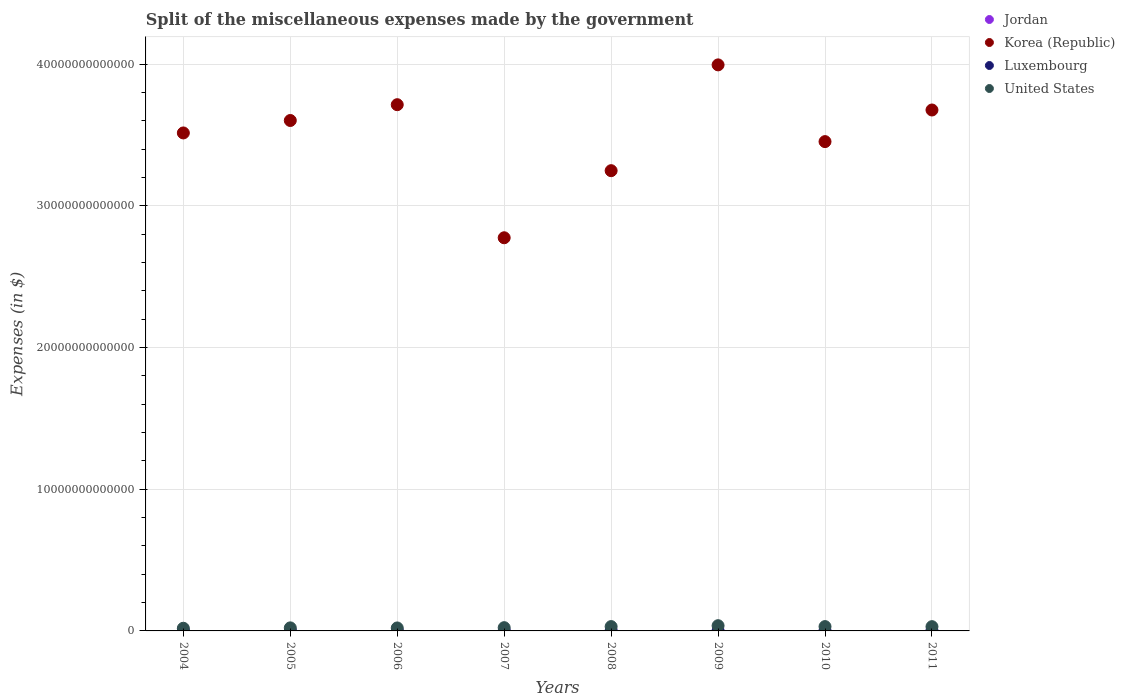How many different coloured dotlines are there?
Make the answer very short. 4. Is the number of dotlines equal to the number of legend labels?
Offer a very short reply. Yes. What is the miscellaneous expenses made by the government in United States in 2006?
Provide a succinct answer. 2.10e+11. Across all years, what is the maximum miscellaneous expenses made by the government in Korea (Republic)?
Offer a terse response. 3.99e+13. Across all years, what is the minimum miscellaneous expenses made by the government in Korea (Republic)?
Keep it short and to the point. 2.77e+13. In which year was the miscellaneous expenses made by the government in United States maximum?
Offer a terse response. 2009. What is the total miscellaneous expenses made by the government in Luxembourg in the graph?
Give a very brief answer. 8.46e+09. What is the difference between the miscellaneous expenses made by the government in Korea (Republic) in 2009 and that in 2010?
Provide a succinct answer. 5.41e+12. What is the difference between the miscellaneous expenses made by the government in Luxembourg in 2004 and the miscellaneous expenses made by the government in Jordan in 2008?
Offer a very short reply. 1.14e+09. What is the average miscellaneous expenses made by the government in Luxembourg per year?
Offer a terse response. 1.06e+09. In the year 2005, what is the difference between the miscellaneous expenses made by the government in United States and miscellaneous expenses made by the government in Jordan?
Offer a very short reply. 2.15e+11. In how many years, is the miscellaneous expenses made by the government in United States greater than 10000000000000 $?
Make the answer very short. 0. What is the ratio of the miscellaneous expenses made by the government in United States in 2005 to that in 2010?
Offer a terse response. 0.71. Is the miscellaneous expenses made by the government in Korea (Republic) in 2005 less than that in 2010?
Your answer should be compact. No. Is the difference between the miscellaneous expenses made by the government in United States in 2005 and 2006 greater than the difference between the miscellaneous expenses made by the government in Jordan in 2005 and 2006?
Keep it short and to the point. Yes. What is the difference between the highest and the second highest miscellaneous expenses made by the government in Jordan?
Provide a short and direct response. 8.96e+08. What is the difference between the highest and the lowest miscellaneous expenses made by the government in Korea (Republic)?
Your answer should be compact. 1.22e+13. In how many years, is the miscellaneous expenses made by the government in Jordan greater than the average miscellaneous expenses made by the government in Jordan taken over all years?
Keep it short and to the point. 2. Is the sum of the miscellaneous expenses made by the government in Korea (Republic) in 2007 and 2009 greater than the maximum miscellaneous expenses made by the government in Jordan across all years?
Your answer should be very brief. Yes. Does the miscellaneous expenses made by the government in Korea (Republic) monotonically increase over the years?
Provide a short and direct response. No. How many dotlines are there?
Provide a short and direct response. 4. What is the difference between two consecutive major ticks on the Y-axis?
Keep it short and to the point. 1.00e+13. Does the graph contain any zero values?
Keep it short and to the point. No. Does the graph contain grids?
Your answer should be very brief. Yes. Where does the legend appear in the graph?
Offer a terse response. Top right. How many legend labels are there?
Give a very brief answer. 4. What is the title of the graph?
Keep it short and to the point. Split of the miscellaneous expenses made by the government. What is the label or title of the X-axis?
Provide a short and direct response. Years. What is the label or title of the Y-axis?
Offer a terse response. Expenses (in $). What is the Expenses (in $) of Jordan in 2004?
Provide a succinct answer. 3.18e+08. What is the Expenses (in $) in Korea (Republic) in 2004?
Offer a very short reply. 3.51e+13. What is the Expenses (in $) in Luxembourg in 2004?
Give a very brief answer. 1.39e+09. What is the Expenses (in $) of United States in 2004?
Ensure brevity in your answer.  1.88e+11. What is the Expenses (in $) in Jordan in 2005?
Your answer should be very brief. 3.57e+08. What is the Expenses (in $) of Korea (Republic) in 2005?
Offer a terse response. 3.60e+13. What is the Expenses (in $) in Luxembourg in 2005?
Your response must be concise. 8.07e+08. What is the Expenses (in $) of United States in 2005?
Your response must be concise. 2.16e+11. What is the Expenses (in $) of Jordan in 2006?
Your answer should be compact. 5.42e+08. What is the Expenses (in $) in Korea (Republic) in 2006?
Offer a terse response. 3.71e+13. What is the Expenses (in $) of Luxembourg in 2006?
Your response must be concise. 8.93e+08. What is the Expenses (in $) in United States in 2006?
Give a very brief answer. 2.10e+11. What is the Expenses (in $) in Jordan in 2007?
Ensure brevity in your answer.  1.44e+09. What is the Expenses (in $) of Korea (Republic) in 2007?
Give a very brief answer. 2.77e+13. What is the Expenses (in $) in Luxembourg in 2007?
Provide a short and direct response. 9.16e+08. What is the Expenses (in $) in United States in 2007?
Keep it short and to the point. 2.30e+11. What is the Expenses (in $) in Jordan in 2008?
Provide a succinct answer. 2.55e+08. What is the Expenses (in $) in Korea (Republic) in 2008?
Your answer should be very brief. 3.25e+13. What is the Expenses (in $) of Luxembourg in 2008?
Offer a terse response. 9.69e+08. What is the Expenses (in $) of United States in 2008?
Make the answer very short. 3.06e+11. What is the Expenses (in $) of Jordan in 2009?
Offer a very short reply. 7.76e+07. What is the Expenses (in $) in Korea (Republic) in 2009?
Your answer should be very brief. 3.99e+13. What is the Expenses (in $) in Luxembourg in 2009?
Ensure brevity in your answer.  1.04e+09. What is the Expenses (in $) of United States in 2009?
Your answer should be very brief. 3.69e+11. What is the Expenses (in $) of Jordan in 2010?
Your response must be concise. 9.67e+07. What is the Expenses (in $) in Korea (Republic) in 2010?
Offer a very short reply. 3.45e+13. What is the Expenses (in $) in Luxembourg in 2010?
Offer a very short reply. 1.15e+09. What is the Expenses (in $) of United States in 2010?
Give a very brief answer. 3.05e+11. What is the Expenses (in $) of Jordan in 2011?
Your answer should be very brief. 8.67e+07. What is the Expenses (in $) of Korea (Republic) in 2011?
Your answer should be very brief. 3.68e+13. What is the Expenses (in $) of Luxembourg in 2011?
Keep it short and to the point. 1.28e+09. What is the Expenses (in $) of United States in 2011?
Offer a very short reply. 3.01e+11. Across all years, what is the maximum Expenses (in $) in Jordan?
Offer a very short reply. 1.44e+09. Across all years, what is the maximum Expenses (in $) in Korea (Republic)?
Make the answer very short. 3.99e+13. Across all years, what is the maximum Expenses (in $) of Luxembourg?
Provide a short and direct response. 1.39e+09. Across all years, what is the maximum Expenses (in $) in United States?
Your answer should be very brief. 3.69e+11. Across all years, what is the minimum Expenses (in $) of Jordan?
Provide a succinct answer. 7.76e+07. Across all years, what is the minimum Expenses (in $) in Korea (Republic)?
Your response must be concise. 2.77e+13. Across all years, what is the minimum Expenses (in $) of Luxembourg?
Make the answer very short. 8.07e+08. Across all years, what is the minimum Expenses (in $) in United States?
Make the answer very short. 1.88e+11. What is the total Expenses (in $) in Jordan in the graph?
Keep it short and to the point. 3.17e+09. What is the total Expenses (in $) of Korea (Republic) in the graph?
Provide a short and direct response. 2.80e+14. What is the total Expenses (in $) in Luxembourg in the graph?
Make the answer very short. 8.46e+09. What is the total Expenses (in $) in United States in the graph?
Offer a very short reply. 2.12e+12. What is the difference between the Expenses (in $) of Jordan in 2004 and that in 2005?
Give a very brief answer. -3.92e+07. What is the difference between the Expenses (in $) in Korea (Republic) in 2004 and that in 2005?
Offer a very short reply. -8.79e+11. What is the difference between the Expenses (in $) of Luxembourg in 2004 and that in 2005?
Your answer should be compact. 5.87e+08. What is the difference between the Expenses (in $) in United States in 2004 and that in 2005?
Give a very brief answer. -2.72e+1. What is the difference between the Expenses (in $) in Jordan in 2004 and that in 2006?
Offer a very short reply. -2.24e+08. What is the difference between the Expenses (in $) of Korea (Republic) in 2004 and that in 2006?
Provide a short and direct response. -1.99e+12. What is the difference between the Expenses (in $) in Luxembourg in 2004 and that in 2006?
Offer a terse response. 5.02e+08. What is the difference between the Expenses (in $) in United States in 2004 and that in 2006?
Keep it short and to the point. -2.14e+1. What is the difference between the Expenses (in $) of Jordan in 2004 and that in 2007?
Ensure brevity in your answer.  -1.12e+09. What is the difference between the Expenses (in $) of Korea (Republic) in 2004 and that in 2007?
Make the answer very short. 7.40e+12. What is the difference between the Expenses (in $) in Luxembourg in 2004 and that in 2007?
Your response must be concise. 4.79e+08. What is the difference between the Expenses (in $) in United States in 2004 and that in 2007?
Offer a very short reply. -4.16e+1. What is the difference between the Expenses (in $) in Jordan in 2004 and that in 2008?
Your response must be concise. 6.25e+07. What is the difference between the Expenses (in $) in Korea (Republic) in 2004 and that in 2008?
Your response must be concise. 2.66e+12. What is the difference between the Expenses (in $) of Luxembourg in 2004 and that in 2008?
Make the answer very short. 4.26e+08. What is the difference between the Expenses (in $) of United States in 2004 and that in 2008?
Your answer should be compact. -1.18e+11. What is the difference between the Expenses (in $) in Jordan in 2004 and that in 2009?
Give a very brief answer. 2.40e+08. What is the difference between the Expenses (in $) in Korea (Republic) in 2004 and that in 2009?
Give a very brief answer. -4.80e+12. What is the difference between the Expenses (in $) of Luxembourg in 2004 and that in 2009?
Provide a succinct answer. 3.50e+08. What is the difference between the Expenses (in $) of United States in 2004 and that in 2009?
Your answer should be very brief. -1.81e+11. What is the difference between the Expenses (in $) in Jordan in 2004 and that in 2010?
Keep it short and to the point. 2.21e+08. What is the difference between the Expenses (in $) of Korea (Republic) in 2004 and that in 2010?
Offer a very short reply. 6.11e+11. What is the difference between the Expenses (in $) of Luxembourg in 2004 and that in 2010?
Give a very brief answer. 2.46e+08. What is the difference between the Expenses (in $) of United States in 2004 and that in 2010?
Your answer should be compact. -1.17e+11. What is the difference between the Expenses (in $) in Jordan in 2004 and that in 2011?
Your response must be concise. 2.31e+08. What is the difference between the Expenses (in $) in Korea (Republic) in 2004 and that in 2011?
Offer a terse response. -1.62e+12. What is the difference between the Expenses (in $) of Luxembourg in 2004 and that in 2011?
Offer a very short reply. 1.10e+08. What is the difference between the Expenses (in $) of United States in 2004 and that in 2011?
Make the answer very short. -1.12e+11. What is the difference between the Expenses (in $) of Jordan in 2005 and that in 2006?
Keep it short and to the point. -1.85e+08. What is the difference between the Expenses (in $) of Korea (Republic) in 2005 and that in 2006?
Provide a short and direct response. -1.12e+12. What is the difference between the Expenses (in $) of Luxembourg in 2005 and that in 2006?
Offer a terse response. -8.55e+07. What is the difference between the Expenses (in $) of United States in 2005 and that in 2006?
Offer a very short reply. 5.80e+09. What is the difference between the Expenses (in $) in Jordan in 2005 and that in 2007?
Provide a short and direct response. -1.08e+09. What is the difference between the Expenses (in $) of Korea (Republic) in 2005 and that in 2007?
Your answer should be compact. 8.28e+12. What is the difference between the Expenses (in $) of Luxembourg in 2005 and that in 2007?
Offer a very short reply. -1.09e+08. What is the difference between the Expenses (in $) in United States in 2005 and that in 2007?
Keep it short and to the point. -1.44e+1. What is the difference between the Expenses (in $) in Jordan in 2005 and that in 2008?
Ensure brevity in your answer.  1.02e+08. What is the difference between the Expenses (in $) of Korea (Republic) in 2005 and that in 2008?
Offer a very short reply. 3.54e+12. What is the difference between the Expenses (in $) in Luxembourg in 2005 and that in 2008?
Give a very brief answer. -1.62e+08. What is the difference between the Expenses (in $) in United States in 2005 and that in 2008?
Your response must be concise. -9.04e+1. What is the difference between the Expenses (in $) in Jordan in 2005 and that in 2009?
Offer a terse response. 2.80e+08. What is the difference between the Expenses (in $) of Korea (Republic) in 2005 and that in 2009?
Offer a very short reply. -3.93e+12. What is the difference between the Expenses (in $) in Luxembourg in 2005 and that in 2009?
Your response must be concise. -2.37e+08. What is the difference between the Expenses (in $) in United States in 2005 and that in 2009?
Provide a short and direct response. -1.54e+11. What is the difference between the Expenses (in $) in Jordan in 2005 and that in 2010?
Make the answer very short. 2.60e+08. What is the difference between the Expenses (in $) of Korea (Republic) in 2005 and that in 2010?
Offer a very short reply. 1.49e+12. What is the difference between the Expenses (in $) in Luxembourg in 2005 and that in 2010?
Offer a terse response. -3.41e+08. What is the difference between the Expenses (in $) in United States in 2005 and that in 2010?
Your answer should be compact. -8.99e+1. What is the difference between the Expenses (in $) of Jordan in 2005 and that in 2011?
Make the answer very short. 2.70e+08. What is the difference between the Expenses (in $) in Korea (Republic) in 2005 and that in 2011?
Provide a short and direct response. -7.41e+11. What is the difference between the Expenses (in $) in Luxembourg in 2005 and that in 2011?
Keep it short and to the point. -4.77e+08. What is the difference between the Expenses (in $) of United States in 2005 and that in 2011?
Offer a very short reply. -8.51e+1. What is the difference between the Expenses (in $) of Jordan in 2006 and that in 2007?
Give a very brief answer. -8.96e+08. What is the difference between the Expenses (in $) of Korea (Republic) in 2006 and that in 2007?
Ensure brevity in your answer.  9.39e+12. What is the difference between the Expenses (in $) in Luxembourg in 2006 and that in 2007?
Offer a very short reply. -2.33e+07. What is the difference between the Expenses (in $) of United States in 2006 and that in 2007?
Give a very brief answer. -2.02e+1. What is the difference between the Expenses (in $) in Jordan in 2006 and that in 2008?
Make the answer very short. 2.87e+08. What is the difference between the Expenses (in $) in Korea (Republic) in 2006 and that in 2008?
Keep it short and to the point. 4.66e+12. What is the difference between the Expenses (in $) of Luxembourg in 2006 and that in 2008?
Keep it short and to the point. -7.64e+07. What is the difference between the Expenses (in $) in United States in 2006 and that in 2008?
Provide a short and direct response. -9.62e+1. What is the difference between the Expenses (in $) in Jordan in 2006 and that in 2009?
Provide a succinct answer. 4.65e+08. What is the difference between the Expenses (in $) in Korea (Republic) in 2006 and that in 2009?
Provide a short and direct response. -2.81e+12. What is the difference between the Expenses (in $) in Luxembourg in 2006 and that in 2009?
Your response must be concise. -1.52e+08. What is the difference between the Expenses (in $) of United States in 2006 and that in 2009?
Provide a succinct answer. -1.60e+11. What is the difference between the Expenses (in $) in Jordan in 2006 and that in 2010?
Keep it short and to the point. 4.46e+08. What is the difference between the Expenses (in $) in Korea (Republic) in 2006 and that in 2010?
Offer a terse response. 2.61e+12. What is the difference between the Expenses (in $) of Luxembourg in 2006 and that in 2010?
Your answer should be very brief. -2.56e+08. What is the difference between the Expenses (in $) of United States in 2006 and that in 2010?
Give a very brief answer. -9.57e+1. What is the difference between the Expenses (in $) in Jordan in 2006 and that in 2011?
Offer a terse response. 4.56e+08. What is the difference between the Expenses (in $) of Korea (Republic) in 2006 and that in 2011?
Provide a succinct answer. 3.75e+11. What is the difference between the Expenses (in $) in Luxembourg in 2006 and that in 2011?
Your answer should be compact. -3.92e+08. What is the difference between the Expenses (in $) in United States in 2006 and that in 2011?
Your response must be concise. -9.09e+1. What is the difference between the Expenses (in $) of Jordan in 2007 and that in 2008?
Give a very brief answer. 1.18e+09. What is the difference between the Expenses (in $) in Korea (Republic) in 2007 and that in 2008?
Your answer should be compact. -4.73e+12. What is the difference between the Expenses (in $) in Luxembourg in 2007 and that in 2008?
Your answer should be compact. -5.31e+07. What is the difference between the Expenses (in $) in United States in 2007 and that in 2008?
Offer a terse response. -7.60e+1. What is the difference between the Expenses (in $) in Jordan in 2007 and that in 2009?
Make the answer very short. 1.36e+09. What is the difference between the Expenses (in $) of Korea (Republic) in 2007 and that in 2009?
Offer a very short reply. -1.22e+13. What is the difference between the Expenses (in $) in Luxembourg in 2007 and that in 2009?
Offer a terse response. -1.28e+08. What is the difference between the Expenses (in $) in United States in 2007 and that in 2009?
Provide a succinct answer. -1.39e+11. What is the difference between the Expenses (in $) in Jordan in 2007 and that in 2010?
Offer a very short reply. 1.34e+09. What is the difference between the Expenses (in $) of Korea (Republic) in 2007 and that in 2010?
Keep it short and to the point. -6.79e+12. What is the difference between the Expenses (in $) of Luxembourg in 2007 and that in 2010?
Make the answer very short. -2.33e+08. What is the difference between the Expenses (in $) of United States in 2007 and that in 2010?
Provide a succinct answer. -7.55e+1. What is the difference between the Expenses (in $) in Jordan in 2007 and that in 2011?
Your answer should be compact. 1.35e+09. What is the difference between the Expenses (in $) of Korea (Republic) in 2007 and that in 2011?
Offer a terse response. -9.02e+12. What is the difference between the Expenses (in $) in Luxembourg in 2007 and that in 2011?
Your answer should be compact. -3.69e+08. What is the difference between the Expenses (in $) of United States in 2007 and that in 2011?
Provide a succinct answer. -7.07e+1. What is the difference between the Expenses (in $) of Jordan in 2008 and that in 2009?
Keep it short and to the point. 1.78e+08. What is the difference between the Expenses (in $) in Korea (Republic) in 2008 and that in 2009?
Give a very brief answer. -7.47e+12. What is the difference between the Expenses (in $) in Luxembourg in 2008 and that in 2009?
Offer a very short reply. -7.53e+07. What is the difference between the Expenses (in $) in United States in 2008 and that in 2009?
Provide a succinct answer. -6.33e+1. What is the difference between the Expenses (in $) in Jordan in 2008 and that in 2010?
Your response must be concise. 1.59e+08. What is the difference between the Expenses (in $) in Korea (Republic) in 2008 and that in 2010?
Your answer should be very brief. -2.05e+12. What is the difference between the Expenses (in $) of Luxembourg in 2008 and that in 2010?
Offer a terse response. -1.79e+08. What is the difference between the Expenses (in $) of Jordan in 2008 and that in 2011?
Your answer should be compact. 1.69e+08. What is the difference between the Expenses (in $) of Korea (Republic) in 2008 and that in 2011?
Your response must be concise. -4.28e+12. What is the difference between the Expenses (in $) in Luxembourg in 2008 and that in 2011?
Your answer should be compact. -3.15e+08. What is the difference between the Expenses (in $) in United States in 2008 and that in 2011?
Offer a terse response. 5.30e+09. What is the difference between the Expenses (in $) of Jordan in 2009 and that in 2010?
Provide a succinct answer. -1.91e+07. What is the difference between the Expenses (in $) of Korea (Republic) in 2009 and that in 2010?
Your answer should be compact. 5.41e+12. What is the difference between the Expenses (in $) of Luxembourg in 2009 and that in 2010?
Your answer should be very brief. -1.04e+08. What is the difference between the Expenses (in $) in United States in 2009 and that in 2010?
Give a very brief answer. 6.38e+1. What is the difference between the Expenses (in $) in Jordan in 2009 and that in 2011?
Your response must be concise. -9.10e+06. What is the difference between the Expenses (in $) of Korea (Republic) in 2009 and that in 2011?
Offer a terse response. 3.18e+12. What is the difference between the Expenses (in $) of Luxembourg in 2009 and that in 2011?
Offer a terse response. -2.40e+08. What is the difference between the Expenses (in $) in United States in 2009 and that in 2011?
Offer a terse response. 6.86e+1. What is the difference between the Expenses (in $) in Korea (Republic) in 2010 and that in 2011?
Provide a short and direct response. -2.23e+12. What is the difference between the Expenses (in $) of Luxembourg in 2010 and that in 2011?
Make the answer very short. -1.36e+08. What is the difference between the Expenses (in $) of United States in 2010 and that in 2011?
Ensure brevity in your answer.  4.80e+09. What is the difference between the Expenses (in $) of Jordan in 2004 and the Expenses (in $) of Korea (Republic) in 2005?
Provide a succinct answer. -3.60e+13. What is the difference between the Expenses (in $) of Jordan in 2004 and the Expenses (in $) of Luxembourg in 2005?
Provide a succinct answer. -4.89e+08. What is the difference between the Expenses (in $) of Jordan in 2004 and the Expenses (in $) of United States in 2005?
Offer a very short reply. -2.15e+11. What is the difference between the Expenses (in $) in Korea (Republic) in 2004 and the Expenses (in $) in Luxembourg in 2005?
Your answer should be compact. 3.51e+13. What is the difference between the Expenses (in $) in Korea (Republic) in 2004 and the Expenses (in $) in United States in 2005?
Make the answer very short. 3.49e+13. What is the difference between the Expenses (in $) in Luxembourg in 2004 and the Expenses (in $) in United States in 2005?
Your response must be concise. -2.14e+11. What is the difference between the Expenses (in $) in Jordan in 2004 and the Expenses (in $) in Korea (Republic) in 2006?
Offer a very short reply. -3.71e+13. What is the difference between the Expenses (in $) of Jordan in 2004 and the Expenses (in $) of Luxembourg in 2006?
Provide a succinct answer. -5.75e+08. What is the difference between the Expenses (in $) in Jordan in 2004 and the Expenses (in $) in United States in 2006?
Offer a very short reply. -2.09e+11. What is the difference between the Expenses (in $) of Korea (Republic) in 2004 and the Expenses (in $) of Luxembourg in 2006?
Provide a succinct answer. 3.51e+13. What is the difference between the Expenses (in $) of Korea (Republic) in 2004 and the Expenses (in $) of United States in 2006?
Offer a terse response. 3.49e+13. What is the difference between the Expenses (in $) of Luxembourg in 2004 and the Expenses (in $) of United States in 2006?
Ensure brevity in your answer.  -2.08e+11. What is the difference between the Expenses (in $) of Jordan in 2004 and the Expenses (in $) of Korea (Republic) in 2007?
Your response must be concise. -2.77e+13. What is the difference between the Expenses (in $) of Jordan in 2004 and the Expenses (in $) of Luxembourg in 2007?
Your answer should be compact. -5.98e+08. What is the difference between the Expenses (in $) in Jordan in 2004 and the Expenses (in $) in United States in 2007?
Provide a short and direct response. -2.30e+11. What is the difference between the Expenses (in $) of Korea (Republic) in 2004 and the Expenses (in $) of Luxembourg in 2007?
Provide a succinct answer. 3.51e+13. What is the difference between the Expenses (in $) in Korea (Republic) in 2004 and the Expenses (in $) in United States in 2007?
Provide a short and direct response. 3.49e+13. What is the difference between the Expenses (in $) of Luxembourg in 2004 and the Expenses (in $) of United States in 2007?
Make the answer very short. -2.29e+11. What is the difference between the Expenses (in $) of Jordan in 2004 and the Expenses (in $) of Korea (Republic) in 2008?
Give a very brief answer. -3.25e+13. What is the difference between the Expenses (in $) of Jordan in 2004 and the Expenses (in $) of Luxembourg in 2008?
Give a very brief answer. -6.51e+08. What is the difference between the Expenses (in $) in Jordan in 2004 and the Expenses (in $) in United States in 2008?
Your answer should be very brief. -3.06e+11. What is the difference between the Expenses (in $) in Korea (Republic) in 2004 and the Expenses (in $) in Luxembourg in 2008?
Give a very brief answer. 3.51e+13. What is the difference between the Expenses (in $) in Korea (Republic) in 2004 and the Expenses (in $) in United States in 2008?
Offer a terse response. 3.48e+13. What is the difference between the Expenses (in $) of Luxembourg in 2004 and the Expenses (in $) of United States in 2008?
Your answer should be compact. -3.05e+11. What is the difference between the Expenses (in $) in Jordan in 2004 and the Expenses (in $) in Korea (Republic) in 2009?
Offer a terse response. -3.99e+13. What is the difference between the Expenses (in $) in Jordan in 2004 and the Expenses (in $) in Luxembourg in 2009?
Offer a terse response. -7.27e+08. What is the difference between the Expenses (in $) in Jordan in 2004 and the Expenses (in $) in United States in 2009?
Your answer should be very brief. -3.69e+11. What is the difference between the Expenses (in $) in Korea (Republic) in 2004 and the Expenses (in $) in Luxembourg in 2009?
Make the answer very short. 3.51e+13. What is the difference between the Expenses (in $) of Korea (Republic) in 2004 and the Expenses (in $) of United States in 2009?
Keep it short and to the point. 3.48e+13. What is the difference between the Expenses (in $) of Luxembourg in 2004 and the Expenses (in $) of United States in 2009?
Your response must be concise. -3.68e+11. What is the difference between the Expenses (in $) in Jordan in 2004 and the Expenses (in $) in Korea (Republic) in 2010?
Give a very brief answer. -3.45e+13. What is the difference between the Expenses (in $) of Jordan in 2004 and the Expenses (in $) of Luxembourg in 2010?
Your response must be concise. -8.31e+08. What is the difference between the Expenses (in $) of Jordan in 2004 and the Expenses (in $) of United States in 2010?
Make the answer very short. -3.05e+11. What is the difference between the Expenses (in $) in Korea (Republic) in 2004 and the Expenses (in $) in Luxembourg in 2010?
Offer a terse response. 3.51e+13. What is the difference between the Expenses (in $) in Korea (Republic) in 2004 and the Expenses (in $) in United States in 2010?
Make the answer very short. 3.48e+13. What is the difference between the Expenses (in $) of Luxembourg in 2004 and the Expenses (in $) of United States in 2010?
Provide a succinct answer. -3.04e+11. What is the difference between the Expenses (in $) of Jordan in 2004 and the Expenses (in $) of Korea (Republic) in 2011?
Make the answer very short. -3.68e+13. What is the difference between the Expenses (in $) of Jordan in 2004 and the Expenses (in $) of Luxembourg in 2011?
Make the answer very short. -9.67e+08. What is the difference between the Expenses (in $) of Jordan in 2004 and the Expenses (in $) of United States in 2011?
Keep it short and to the point. -3.00e+11. What is the difference between the Expenses (in $) in Korea (Republic) in 2004 and the Expenses (in $) in Luxembourg in 2011?
Keep it short and to the point. 3.51e+13. What is the difference between the Expenses (in $) of Korea (Republic) in 2004 and the Expenses (in $) of United States in 2011?
Offer a terse response. 3.48e+13. What is the difference between the Expenses (in $) of Luxembourg in 2004 and the Expenses (in $) of United States in 2011?
Provide a succinct answer. -2.99e+11. What is the difference between the Expenses (in $) of Jordan in 2005 and the Expenses (in $) of Korea (Republic) in 2006?
Your response must be concise. -3.71e+13. What is the difference between the Expenses (in $) of Jordan in 2005 and the Expenses (in $) of Luxembourg in 2006?
Your answer should be compact. -5.36e+08. What is the difference between the Expenses (in $) in Jordan in 2005 and the Expenses (in $) in United States in 2006?
Provide a succinct answer. -2.09e+11. What is the difference between the Expenses (in $) in Korea (Republic) in 2005 and the Expenses (in $) in Luxembourg in 2006?
Make the answer very short. 3.60e+13. What is the difference between the Expenses (in $) in Korea (Republic) in 2005 and the Expenses (in $) in United States in 2006?
Make the answer very short. 3.58e+13. What is the difference between the Expenses (in $) in Luxembourg in 2005 and the Expenses (in $) in United States in 2006?
Ensure brevity in your answer.  -2.09e+11. What is the difference between the Expenses (in $) of Jordan in 2005 and the Expenses (in $) of Korea (Republic) in 2007?
Provide a succinct answer. -2.77e+13. What is the difference between the Expenses (in $) in Jordan in 2005 and the Expenses (in $) in Luxembourg in 2007?
Ensure brevity in your answer.  -5.59e+08. What is the difference between the Expenses (in $) of Jordan in 2005 and the Expenses (in $) of United States in 2007?
Make the answer very short. -2.30e+11. What is the difference between the Expenses (in $) of Korea (Republic) in 2005 and the Expenses (in $) of Luxembourg in 2007?
Offer a very short reply. 3.60e+13. What is the difference between the Expenses (in $) in Korea (Republic) in 2005 and the Expenses (in $) in United States in 2007?
Make the answer very short. 3.58e+13. What is the difference between the Expenses (in $) in Luxembourg in 2005 and the Expenses (in $) in United States in 2007?
Make the answer very short. -2.29e+11. What is the difference between the Expenses (in $) in Jordan in 2005 and the Expenses (in $) in Korea (Republic) in 2008?
Your answer should be very brief. -3.25e+13. What is the difference between the Expenses (in $) of Jordan in 2005 and the Expenses (in $) of Luxembourg in 2008?
Give a very brief answer. -6.12e+08. What is the difference between the Expenses (in $) in Jordan in 2005 and the Expenses (in $) in United States in 2008?
Make the answer very short. -3.06e+11. What is the difference between the Expenses (in $) in Korea (Republic) in 2005 and the Expenses (in $) in Luxembourg in 2008?
Offer a terse response. 3.60e+13. What is the difference between the Expenses (in $) of Korea (Republic) in 2005 and the Expenses (in $) of United States in 2008?
Keep it short and to the point. 3.57e+13. What is the difference between the Expenses (in $) of Luxembourg in 2005 and the Expenses (in $) of United States in 2008?
Keep it short and to the point. -3.05e+11. What is the difference between the Expenses (in $) of Jordan in 2005 and the Expenses (in $) of Korea (Republic) in 2009?
Your answer should be very brief. -3.99e+13. What is the difference between the Expenses (in $) of Jordan in 2005 and the Expenses (in $) of Luxembourg in 2009?
Keep it short and to the point. -6.87e+08. What is the difference between the Expenses (in $) of Jordan in 2005 and the Expenses (in $) of United States in 2009?
Offer a terse response. -3.69e+11. What is the difference between the Expenses (in $) of Korea (Republic) in 2005 and the Expenses (in $) of Luxembourg in 2009?
Offer a terse response. 3.60e+13. What is the difference between the Expenses (in $) in Korea (Republic) in 2005 and the Expenses (in $) in United States in 2009?
Your response must be concise. 3.57e+13. What is the difference between the Expenses (in $) in Luxembourg in 2005 and the Expenses (in $) in United States in 2009?
Your answer should be very brief. -3.68e+11. What is the difference between the Expenses (in $) of Jordan in 2005 and the Expenses (in $) of Korea (Republic) in 2010?
Offer a very short reply. -3.45e+13. What is the difference between the Expenses (in $) of Jordan in 2005 and the Expenses (in $) of Luxembourg in 2010?
Keep it short and to the point. -7.91e+08. What is the difference between the Expenses (in $) in Jordan in 2005 and the Expenses (in $) in United States in 2010?
Provide a succinct answer. -3.05e+11. What is the difference between the Expenses (in $) of Korea (Republic) in 2005 and the Expenses (in $) of Luxembourg in 2010?
Offer a terse response. 3.60e+13. What is the difference between the Expenses (in $) of Korea (Republic) in 2005 and the Expenses (in $) of United States in 2010?
Provide a succinct answer. 3.57e+13. What is the difference between the Expenses (in $) of Luxembourg in 2005 and the Expenses (in $) of United States in 2010?
Your answer should be compact. -3.05e+11. What is the difference between the Expenses (in $) in Jordan in 2005 and the Expenses (in $) in Korea (Republic) in 2011?
Offer a terse response. -3.68e+13. What is the difference between the Expenses (in $) of Jordan in 2005 and the Expenses (in $) of Luxembourg in 2011?
Your answer should be compact. -9.27e+08. What is the difference between the Expenses (in $) of Jordan in 2005 and the Expenses (in $) of United States in 2011?
Offer a very short reply. -3.00e+11. What is the difference between the Expenses (in $) of Korea (Republic) in 2005 and the Expenses (in $) of Luxembourg in 2011?
Your answer should be compact. 3.60e+13. What is the difference between the Expenses (in $) in Korea (Republic) in 2005 and the Expenses (in $) in United States in 2011?
Provide a short and direct response. 3.57e+13. What is the difference between the Expenses (in $) in Luxembourg in 2005 and the Expenses (in $) in United States in 2011?
Ensure brevity in your answer.  -3.00e+11. What is the difference between the Expenses (in $) of Jordan in 2006 and the Expenses (in $) of Korea (Republic) in 2007?
Give a very brief answer. -2.77e+13. What is the difference between the Expenses (in $) in Jordan in 2006 and the Expenses (in $) in Luxembourg in 2007?
Ensure brevity in your answer.  -3.74e+08. What is the difference between the Expenses (in $) in Jordan in 2006 and the Expenses (in $) in United States in 2007?
Offer a terse response. -2.29e+11. What is the difference between the Expenses (in $) in Korea (Republic) in 2006 and the Expenses (in $) in Luxembourg in 2007?
Keep it short and to the point. 3.71e+13. What is the difference between the Expenses (in $) in Korea (Republic) in 2006 and the Expenses (in $) in United States in 2007?
Offer a terse response. 3.69e+13. What is the difference between the Expenses (in $) in Luxembourg in 2006 and the Expenses (in $) in United States in 2007?
Offer a terse response. -2.29e+11. What is the difference between the Expenses (in $) of Jordan in 2006 and the Expenses (in $) of Korea (Republic) in 2008?
Provide a short and direct response. -3.25e+13. What is the difference between the Expenses (in $) in Jordan in 2006 and the Expenses (in $) in Luxembourg in 2008?
Ensure brevity in your answer.  -4.27e+08. What is the difference between the Expenses (in $) in Jordan in 2006 and the Expenses (in $) in United States in 2008?
Provide a short and direct response. -3.05e+11. What is the difference between the Expenses (in $) in Korea (Republic) in 2006 and the Expenses (in $) in Luxembourg in 2008?
Your answer should be very brief. 3.71e+13. What is the difference between the Expenses (in $) of Korea (Republic) in 2006 and the Expenses (in $) of United States in 2008?
Keep it short and to the point. 3.68e+13. What is the difference between the Expenses (in $) in Luxembourg in 2006 and the Expenses (in $) in United States in 2008?
Ensure brevity in your answer.  -3.05e+11. What is the difference between the Expenses (in $) of Jordan in 2006 and the Expenses (in $) of Korea (Republic) in 2009?
Offer a terse response. -3.99e+13. What is the difference between the Expenses (in $) in Jordan in 2006 and the Expenses (in $) in Luxembourg in 2009?
Give a very brief answer. -5.02e+08. What is the difference between the Expenses (in $) in Jordan in 2006 and the Expenses (in $) in United States in 2009?
Your answer should be very brief. -3.69e+11. What is the difference between the Expenses (in $) in Korea (Republic) in 2006 and the Expenses (in $) in Luxembourg in 2009?
Make the answer very short. 3.71e+13. What is the difference between the Expenses (in $) in Korea (Republic) in 2006 and the Expenses (in $) in United States in 2009?
Ensure brevity in your answer.  3.68e+13. What is the difference between the Expenses (in $) of Luxembourg in 2006 and the Expenses (in $) of United States in 2009?
Provide a short and direct response. -3.68e+11. What is the difference between the Expenses (in $) in Jordan in 2006 and the Expenses (in $) in Korea (Republic) in 2010?
Make the answer very short. -3.45e+13. What is the difference between the Expenses (in $) of Jordan in 2006 and the Expenses (in $) of Luxembourg in 2010?
Give a very brief answer. -6.06e+08. What is the difference between the Expenses (in $) in Jordan in 2006 and the Expenses (in $) in United States in 2010?
Your response must be concise. -3.05e+11. What is the difference between the Expenses (in $) of Korea (Republic) in 2006 and the Expenses (in $) of Luxembourg in 2010?
Your answer should be compact. 3.71e+13. What is the difference between the Expenses (in $) in Korea (Republic) in 2006 and the Expenses (in $) in United States in 2010?
Your response must be concise. 3.68e+13. What is the difference between the Expenses (in $) of Luxembourg in 2006 and the Expenses (in $) of United States in 2010?
Ensure brevity in your answer.  -3.05e+11. What is the difference between the Expenses (in $) in Jordan in 2006 and the Expenses (in $) in Korea (Republic) in 2011?
Make the answer very short. -3.68e+13. What is the difference between the Expenses (in $) of Jordan in 2006 and the Expenses (in $) of Luxembourg in 2011?
Your answer should be compact. -7.42e+08. What is the difference between the Expenses (in $) in Jordan in 2006 and the Expenses (in $) in United States in 2011?
Ensure brevity in your answer.  -3.00e+11. What is the difference between the Expenses (in $) in Korea (Republic) in 2006 and the Expenses (in $) in Luxembourg in 2011?
Keep it short and to the point. 3.71e+13. What is the difference between the Expenses (in $) of Korea (Republic) in 2006 and the Expenses (in $) of United States in 2011?
Provide a succinct answer. 3.68e+13. What is the difference between the Expenses (in $) of Luxembourg in 2006 and the Expenses (in $) of United States in 2011?
Your answer should be compact. -3.00e+11. What is the difference between the Expenses (in $) of Jordan in 2007 and the Expenses (in $) of Korea (Republic) in 2008?
Provide a succinct answer. -3.25e+13. What is the difference between the Expenses (in $) of Jordan in 2007 and the Expenses (in $) of Luxembourg in 2008?
Offer a terse response. 4.69e+08. What is the difference between the Expenses (in $) in Jordan in 2007 and the Expenses (in $) in United States in 2008?
Ensure brevity in your answer.  -3.04e+11. What is the difference between the Expenses (in $) of Korea (Republic) in 2007 and the Expenses (in $) of Luxembourg in 2008?
Make the answer very short. 2.77e+13. What is the difference between the Expenses (in $) in Korea (Republic) in 2007 and the Expenses (in $) in United States in 2008?
Your response must be concise. 2.74e+13. What is the difference between the Expenses (in $) of Luxembourg in 2007 and the Expenses (in $) of United States in 2008?
Your response must be concise. -3.05e+11. What is the difference between the Expenses (in $) in Jordan in 2007 and the Expenses (in $) in Korea (Republic) in 2009?
Provide a short and direct response. -3.99e+13. What is the difference between the Expenses (in $) in Jordan in 2007 and the Expenses (in $) in Luxembourg in 2009?
Provide a short and direct response. 3.94e+08. What is the difference between the Expenses (in $) of Jordan in 2007 and the Expenses (in $) of United States in 2009?
Your response must be concise. -3.68e+11. What is the difference between the Expenses (in $) in Korea (Republic) in 2007 and the Expenses (in $) in Luxembourg in 2009?
Offer a very short reply. 2.77e+13. What is the difference between the Expenses (in $) in Korea (Republic) in 2007 and the Expenses (in $) in United States in 2009?
Provide a short and direct response. 2.74e+13. What is the difference between the Expenses (in $) of Luxembourg in 2007 and the Expenses (in $) of United States in 2009?
Your response must be concise. -3.68e+11. What is the difference between the Expenses (in $) in Jordan in 2007 and the Expenses (in $) in Korea (Republic) in 2010?
Your response must be concise. -3.45e+13. What is the difference between the Expenses (in $) of Jordan in 2007 and the Expenses (in $) of Luxembourg in 2010?
Your response must be concise. 2.90e+08. What is the difference between the Expenses (in $) in Jordan in 2007 and the Expenses (in $) in United States in 2010?
Give a very brief answer. -3.04e+11. What is the difference between the Expenses (in $) in Korea (Republic) in 2007 and the Expenses (in $) in Luxembourg in 2010?
Provide a succinct answer. 2.77e+13. What is the difference between the Expenses (in $) in Korea (Republic) in 2007 and the Expenses (in $) in United States in 2010?
Offer a terse response. 2.74e+13. What is the difference between the Expenses (in $) of Luxembourg in 2007 and the Expenses (in $) of United States in 2010?
Make the answer very short. -3.04e+11. What is the difference between the Expenses (in $) in Jordan in 2007 and the Expenses (in $) in Korea (Republic) in 2011?
Make the answer very short. -3.68e+13. What is the difference between the Expenses (in $) in Jordan in 2007 and the Expenses (in $) in Luxembourg in 2011?
Your answer should be very brief. 1.54e+08. What is the difference between the Expenses (in $) in Jordan in 2007 and the Expenses (in $) in United States in 2011?
Give a very brief answer. -2.99e+11. What is the difference between the Expenses (in $) of Korea (Republic) in 2007 and the Expenses (in $) of Luxembourg in 2011?
Offer a terse response. 2.77e+13. What is the difference between the Expenses (in $) of Korea (Republic) in 2007 and the Expenses (in $) of United States in 2011?
Provide a succinct answer. 2.74e+13. What is the difference between the Expenses (in $) of Luxembourg in 2007 and the Expenses (in $) of United States in 2011?
Provide a succinct answer. -3.00e+11. What is the difference between the Expenses (in $) in Jordan in 2008 and the Expenses (in $) in Korea (Republic) in 2009?
Offer a very short reply. -3.99e+13. What is the difference between the Expenses (in $) of Jordan in 2008 and the Expenses (in $) of Luxembourg in 2009?
Offer a very short reply. -7.89e+08. What is the difference between the Expenses (in $) of Jordan in 2008 and the Expenses (in $) of United States in 2009?
Keep it short and to the point. -3.69e+11. What is the difference between the Expenses (in $) in Korea (Republic) in 2008 and the Expenses (in $) in Luxembourg in 2009?
Keep it short and to the point. 3.25e+13. What is the difference between the Expenses (in $) of Korea (Republic) in 2008 and the Expenses (in $) of United States in 2009?
Provide a succinct answer. 3.21e+13. What is the difference between the Expenses (in $) in Luxembourg in 2008 and the Expenses (in $) in United States in 2009?
Your answer should be very brief. -3.68e+11. What is the difference between the Expenses (in $) in Jordan in 2008 and the Expenses (in $) in Korea (Republic) in 2010?
Keep it short and to the point. -3.45e+13. What is the difference between the Expenses (in $) of Jordan in 2008 and the Expenses (in $) of Luxembourg in 2010?
Provide a short and direct response. -8.93e+08. What is the difference between the Expenses (in $) of Jordan in 2008 and the Expenses (in $) of United States in 2010?
Your answer should be compact. -3.05e+11. What is the difference between the Expenses (in $) of Korea (Republic) in 2008 and the Expenses (in $) of Luxembourg in 2010?
Give a very brief answer. 3.25e+13. What is the difference between the Expenses (in $) of Korea (Republic) in 2008 and the Expenses (in $) of United States in 2010?
Offer a very short reply. 3.22e+13. What is the difference between the Expenses (in $) of Luxembourg in 2008 and the Expenses (in $) of United States in 2010?
Ensure brevity in your answer.  -3.04e+11. What is the difference between the Expenses (in $) of Jordan in 2008 and the Expenses (in $) of Korea (Republic) in 2011?
Your answer should be very brief. -3.68e+13. What is the difference between the Expenses (in $) in Jordan in 2008 and the Expenses (in $) in Luxembourg in 2011?
Offer a very short reply. -1.03e+09. What is the difference between the Expenses (in $) in Jordan in 2008 and the Expenses (in $) in United States in 2011?
Provide a short and direct response. -3.00e+11. What is the difference between the Expenses (in $) in Korea (Republic) in 2008 and the Expenses (in $) in Luxembourg in 2011?
Provide a succinct answer. 3.25e+13. What is the difference between the Expenses (in $) in Korea (Republic) in 2008 and the Expenses (in $) in United States in 2011?
Give a very brief answer. 3.22e+13. What is the difference between the Expenses (in $) of Luxembourg in 2008 and the Expenses (in $) of United States in 2011?
Provide a succinct answer. -3.00e+11. What is the difference between the Expenses (in $) of Jordan in 2009 and the Expenses (in $) of Korea (Republic) in 2010?
Make the answer very short. -3.45e+13. What is the difference between the Expenses (in $) of Jordan in 2009 and the Expenses (in $) of Luxembourg in 2010?
Your answer should be compact. -1.07e+09. What is the difference between the Expenses (in $) in Jordan in 2009 and the Expenses (in $) in United States in 2010?
Your answer should be very brief. -3.05e+11. What is the difference between the Expenses (in $) in Korea (Republic) in 2009 and the Expenses (in $) in Luxembourg in 2010?
Offer a terse response. 3.99e+13. What is the difference between the Expenses (in $) of Korea (Republic) in 2009 and the Expenses (in $) of United States in 2010?
Provide a succinct answer. 3.96e+13. What is the difference between the Expenses (in $) of Luxembourg in 2009 and the Expenses (in $) of United States in 2010?
Your answer should be compact. -3.04e+11. What is the difference between the Expenses (in $) of Jordan in 2009 and the Expenses (in $) of Korea (Republic) in 2011?
Give a very brief answer. -3.68e+13. What is the difference between the Expenses (in $) of Jordan in 2009 and the Expenses (in $) of Luxembourg in 2011?
Your answer should be very brief. -1.21e+09. What is the difference between the Expenses (in $) of Jordan in 2009 and the Expenses (in $) of United States in 2011?
Your response must be concise. -3.01e+11. What is the difference between the Expenses (in $) in Korea (Republic) in 2009 and the Expenses (in $) in Luxembourg in 2011?
Keep it short and to the point. 3.99e+13. What is the difference between the Expenses (in $) of Korea (Republic) in 2009 and the Expenses (in $) of United States in 2011?
Make the answer very short. 3.96e+13. What is the difference between the Expenses (in $) in Luxembourg in 2009 and the Expenses (in $) in United States in 2011?
Your response must be concise. -3.00e+11. What is the difference between the Expenses (in $) in Jordan in 2010 and the Expenses (in $) in Korea (Republic) in 2011?
Make the answer very short. -3.68e+13. What is the difference between the Expenses (in $) of Jordan in 2010 and the Expenses (in $) of Luxembourg in 2011?
Offer a very short reply. -1.19e+09. What is the difference between the Expenses (in $) of Jordan in 2010 and the Expenses (in $) of United States in 2011?
Your response must be concise. -3.01e+11. What is the difference between the Expenses (in $) in Korea (Republic) in 2010 and the Expenses (in $) in Luxembourg in 2011?
Your answer should be very brief. 3.45e+13. What is the difference between the Expenses (in $) of Korea (Republic) in 2010 and the Expenses (in $) of United States in 2011?
Your answer should be very brief. 3.42e+13. What is the difference between the Expenses (in $) of Luxembourg in 2010 and the Expenses (in $) of United States in 2011?
Provide a succinct answer. -2.99e+11. What is the average Expenses (in $) in Jordan per year?
Provide a short and direct response. 3.97e+08. What is the average Expenses (in $) of Korea (Republic) per year?
Provide a short and direct response. 3.50e+13. What is the average Expenses (in $) in Luxembourg per year?
Ensure brevity in your answer.  1.06e+09. What is the average Expenses (in $) in United States per year?
Make the answer very short. 2.66e+11. In the year 2004, what is the difference between the Expenses (in $) in Jordan and Expenses (in $) in Korea (Republic)?
Your response must be concise. -3.51e+13. In the year 2004, what is the difference between the Expenses (in $) in Jordan and Expenses (in $) in Luxembourg?
Ensure brevity in your answer.  -1.08e+09. In the year 2004, what is the difference between the Expenses (in $) in Jordan and Expenses (in $) in United States?
Your response must be concise. -1.88e+11. In the year 2004, what is the difference between the Expenses (in $) of Korea (Republic) and Expenses (in $) of Luxembourg?
Your answer should be compact. 3.51e+13. In the year 2004, what is the difference between the Expenses (in $) in Korea (Republic) and Expenses (in $) in United States?
Ensure brevity in your answer.  3.50e+13. In the year 2004, what is the difference between the Expenses (in $) in Luxembourg and Expenses (in $) in United States?
Your response must be concise. -1.87e+11. In the year 2005, what is the difference between the Expenses (in $) of Jordan and Expenses (in $) of Korea (Republic)?
Ensure brevity in your answer.  -3.60e+13. In the year 2005, what is the difference between the Expenses (in $) of Jordan and Expenses (in $) of Luxembourg?
Your answer should be very brief. -4.50e+08. In the year 2005, what is the difference between the Expenses (in $) in Jordan and Expenses (in $) in United States?
Make the answer very short. -2.15e+11. In the year 2005, what is the difference between the Expenses (in $) of Korea (Republic) and Expenses (in $) of Luxembourg?
Provide a short and direct response. 3.60e+13. In the year 2005, what is the difference between the Expenses (in $) in Korea (Republic) and Expenses (in $) in United States?
Provide a short and direct response. 3.58e+13. In the year 2005, what is the difference between the Expenses (in $) in Luxembourg and Expenses (in $) in United States?
Your response must be concise. -2.15e+11. In the year 2006, what is the difference between the Expenses (in $) of Jordan and Expenses (in $) of Korea (Republic)?
Offer a terse response. -3.71e+13. In the year 2006, what is the difference between the Expenses (in $) of Jordan and Expenses (in $) of Luxembourg?
Make the answer very short. -3.50e+08. In the year 2006, what is the difference between the Expenses (in $) in Jordan and Expenses (in $) in United States?
Offer a terse response. -2.09e+11. In the year 2006, what is the difference between the Expenses (in $) of Korea (Republic) and Expenses (in $) of Luxembourg?
Provide a short and direct response. 3.71e+13. In the year 2006, what is the difference between the Expenses (in $) of Korea (Republic) and Expenses (in $) of United States?
Your answer should be very brief. 3.69e+13. In the year 2006, what is the difference between the Expenses (in $) in Luxembourg and Expenses (in $) in United States?
Provide a succinct answer. -2.09e+11. In the year 2007, what is the difference between the Expenses (in $) in Jordan and Expenses (in $) in Korea (Republic)?
Your response must be concise. -2.77e+13. In the year 2007, what is the difference between the Expenses (in $) in Jordan and Expenses (in $) in Luxembourg?
Give a very brief answer. 5.23e+08. In the year 2007, what is the difference between the Expenses (in $) of Jordan and Expenses (in $) of United States?
Provide a short and direct response. -2.28e+11. In the year 2007, what is the difference between the Expenses (in $) in Korea (Republic) and Expenses (in $) in Luxembourg?
Provide a short and direct response. 2.77e+13. In the year 2007, what is the difference between the Expenses (in $) of Korea (Republic) and Expenses (in $) of United States?
Ensure brevity in your answer.  2.75e+13. In the year 2007, what is the difference between the Expenses (in $) in Luxembourg and Expenses (in $) in United States?
Ensure brevity in your answer.  -2.29e+11. In the year 2008, what is the difference between the Expenses (in $) of Jordan and Expenses (in $) of Korea (Republic)?
Offer a very short reply. -3.25e+13. In the year 2008, what is the difference between the Expenses (in $) in Jordan and Expenses (in $) in Luxembourg?
Make the answer very short. -7.14e+08. In the year 2008, what is the difference between the Expenses (in $) in Jordan and Expenses (in $) in United States?
Your answer should be compact. -3.06e+11. In the year 2008, what is the difference between the Expenses (in $) in Korea (Republic) and Expenses (in $) in Luxembourg?
Ensure brevity in your answer.  3.25e+13. In the year 2008, what is the difference between the Expenses (in $) of Korea (Republic) and Expenses (in $) of United States?
Your answer should be compact. 3.22e+13. In the year 2008, what is the difference between the Expenses (in $) of Luxembourg and Expenses (in $) of United States?
Offer a terse response. -3.05e+11. In the year 2009, what is the difference between the Expenses (in $) in Jordan and Expenses (in $) in Korea (Republic)?
Provide a succinct answer. -3.99e+13. In the year 2009, what is the difference between the Expenses (in $) of Jordan and Expenses (in $) of Luxembourg?
Give a very brief answer. -9.67e+08. In the year 2009, what is the difference between the Expenses (in $) in Jordan and Expenses (in $) in United States?
Keep it short and to the point. -3.69e+11. In the year 2009, what is the difference between the Expenses (in $) of Korea (Republic) and Expenses (in $) of Luxembourg?
Your answer should be very brief. 3.99e+13. In the year 2009, what is the difference between the Expenses (in $) of Korea (Republic) and Expenses (in $) of United States?
Make the answer very short. 3.96e+13. In the year 2009, what is the difference between the Expenses (in $) in Luxembourg and Expenses (in $) in United States?
Keep it short and to the point. -3.68e+11. In the year 2010, what is the difference between the Expenses (in $) in Jordan and Expenses (in $) in Korea (Republic)?
Provide a short and direct response. -3.45e+13. In the year 2010, what is the difference between the Expenses (in $) of Jordan and Expenses (in $) of Luxembourg?
Keep it short and to the point. -1.05e+09. In the year 2010, what is the difference between the Expenses (in $) of Jordan and Expenses (in $) of United States?
Provide a short and direct response. -3.05e+11. In the year 2010, what is the difference between the Expenses (in $) in Korea (Republic) and Expenses (in $) in Luxembourg?
Keep it short and to the point. 3.45e+13. In the year 2010, what is the difference between the Expenses (in $) in Korea (Republic) and Expenses (in $) in United States?
Your answer should be very brief. 3.42e+13. In the year 2010, what is the difference between the Expenses (in $) of Luxembourg and Expenses (in $) of United States?
Offer a very short reply. -3.04e+11. In the year 2011, what is the difference between the Expenses (in $) of Jordan and Expenses (in $) of Korea (Republic)?
Ensure brevity in your answer.  -3.68e+13. In the year 2011, what is the difference between the Expenses (in $) of Jordan and Expenses (in $) of Luxembourg?
Offer a very short reply. -1.20e+09. In the year 2011, what is the difference between the Expenses (in $) in Jordan and Expenses (in $) in United States?
Provide a short and direct response. -3.01e+11. In the year 2011, what is the difference between the Expenses (in $) in Korea (Republic) and Expenses (in $) in Luxembourg?
Give a very brief answer. 3.68e+13. In the year 2011, what is the difference between the Expenses (in $) in Korea (Republic) and Expenses (in $) in United States?
Your answer should be compact. 3.65e+13. In the year 2011, what is the difference between the Expenses (in $) in Luxembourg and Expenses (in $) in United States?
Make the answer very short. -2.99e+11. What is the ratio of the Expenses (in $) of Jordan in 2004 to that in 2005?
Your answer should be very brief. 0.89. What is the ratio of the Expenses (in $) in Korea (Republic) in 2004 to that in 2005?
Your answer should be very brief. 0.98. What is the ratio of the Expenses (in $) in Luxembourg in 2004 to that in 2005?
Offer a terse response. 1.73. What is the ratio of the Expenses (in $) of United States in 2004 to that in 2005?
Give a very brief answer. 0.87. What is the ratio of the Expenses (in $) in Jordan in 2004 to that in 2006?
Give a very brief answer. 0.59. What is the ratio of the Expenses (in $) in Korea (Republic) in 2004 to that in 2006?
Make the answer very short. 0.95. What is the ratio of the Expenses (in $) of Luxembourg in 2004 to that in 2006?
Provide a succinct answer. 1.56. What is the ratio of the Expenses (in $) in United States in 2004 to that in 2006?
Provide a short and direct response. 0.9. What is the ratio of the Expenses (in $) in Jordan in 2004 to that in 2007?
Ensure brevity in your answer.  0.22. What is the ratio of the Expenses (in $) of Korea (Republic) in 2004 to that in 2007?
Offer a terse response. 1.27. What is the ratio of the Expenses (in $) in Luxembourg in 2004 to that in 2007?
Offer a very short reply. 1.52. What is the ratio of the Expenses (in $) in United States in 2004 to that in 2007?
Your answer should be very brief. 0.82. What is the ratio of the Expenses (in $) in Jordan in 2004 to that in 2008?
Provide a succinct answer. 1.24. What is the ratio of the Expenses (in $) in Korea (Republic) in 2004 to that in 2008?
Offer a terse response. 1.08. What is the ratio of the Expenses (in $) of Luxembourg in 2004 to that in 2008?
Keep it short and to the point. 1.44. What is the ratio of the Expenses (in $) of United States in 2004 to that in 2008?
Give a very brief answer. 0.62. What is the ratio of the Expenses (in $) of Jordan in 2004 to that in 2009?
Make the answer very short. 4.1. What is the ratio of the Expenses (in $) in Korea (Republic) in 2004 to that in 2009?
Your response must be concise. 0.88. What is the ratio of the Expenses (in $) of Luxembourg in 2004 to that in 2009?
Offer a very short reply. 1.34. What is the ratio of the Expenses (in $) of United States in 2004 to that in 2009?
Keep it short and to the point. 0.51. What is the ratio of the Expenses (in $) in Jordan in 2004 to that in 2010?
Offer a terse response. 3.29. What is the ratio of the Expenses (in $) in Korea (Republic) in 2004 to that in 2010?
Provide a succinct answer. 1.02. What is the ratio of the Expenses (in $) in Luxembourg in 2004 to that in 2010?
Provide a short and direct response. 1.21. What is the ratio of the Expenses (in $) in United States in 2004 to that in 2010?
Ensure brevity in your answer.  0.62. What is the ratio of the Expenses (in $) in Jordan in 2004 to that in 2011?
Give a very brief answer. 3.67. What is the ratio of the Expenses (in $) of Korea (Republic) in 2004 to that in 2011?
Ensure brevity in your answer.  0.96. What is the ratio of the Expenses (in $) of Luxembourg in 2004 to that in 2011?
Keep it short and to the point. 1.09. What is the ratio of the Expenses (in $) in United States in 2004 to that in 2011?
Your response must be concise. 0.63. What is the ratio of the Expenses (in $) of Jordan in 2005 to that in 2006?
Keep it short and to the point. 0.66. What is the ratio of the Expenses (in $) of Korea (Republic) in 2005 to that in 2006?
Your response must be concise. 0.97. What is the ratio of the Expenses (in $) of Luxembourg in 2005 to that in 2006?
Your answer should be very brief. 0.9. What is the ratio of the Expenses (in $) in United States in 2005 to that in 2006?
Provide a short and direct response. 1.03. What is the ratio of the Expenses (in $) in Jordan in 2005 to that in 2007?
Provide a short and direct response. 0.25. What is the ratio of the Expenses (in $) of Korea (Republic) in 2005 to that in 2007?
Provide a short and direct response. 1.3. What is the ratio of the Expenses (in $) in Luxembourg in 2005 to that in 2007?
Make the answer very short. 0.88. What is the ratio of the Expenses (in $) of United States in 2005 to that in 2007?
Offer a terse response. 0.94. What is the ratio of the Expenses (in $) of Jordan in 2005 to that in 2008?
Make the answer very short. 1.4. What is the ratio of the Expenses (in $) in Korea (Republic) in 2005 to that in 2008?
Ensure brevity in your answer.  1.11. What is the ratio of the Expenses (in $) in Luxembourg in 2005 to that in 2008?
Your answer should be compact. 0.83. What is the ratio of the Expenses (in $) of United States in 2005 to that in 2008?
Offer a very short reply. 0.7. What is the ratio of the Expenses (in $) of Jordan in 2005 to that in 2009?
Provide a succinct answer. 4.6. What is the ratio of the Expenses (in $) in Korea (Republic) in 2005 to that in 2009?
Give a very brief answer. 0.9. What is the ratio of the Expenses (in $) of Luxembourg in 2005 to that in 2009?
Provide a short and direct response. 0.77. What is the ratio of the Expenses (in $) of United States in 2005 to that in 2009?
Provide a succinct answer. 0.58. What is the ratio of the Expenses (in $) in Jordan in 2005 to that in 2010?
Your response must be concise. 3.69. What is the ratio of the Expenses (in $) of Korea (Republic) in 2005 to that in 2010?
Offer a terse response. 1.04. What is the ratio of the Expenses (in $) of Luxembourg in 2005 to that in 2010?
Your answer should be very brief. 0.7. What is the ratio of the Expenses (in $) of United States in 2005 to that in 2010?
Give a very brief answer. 0.71. What is the ratio of the Expenses (in $) of Jordan in 2005 to that in 2011?
Provide a succinct answer. 4.12. What is the ratio of the Expenses (in $) in Korea (Republic) in 2005 to that in 2011?
Keep it short and to the point. 0.98. What is the ratio of the Expenses (in $) of Luxembourg in 2005 to that in 2011?
Ensure brevity in your answer.  0.63. What is the ratio of the Expenses (in $) of United States in 2005 to that in 2011?
Make the answer very short. 0.72. What is the ratio of the Expenses (in $) in Jordan in 2006 to that in 2007?
Your answer should be very brief. 0.38. What is the ratio of the Expenses (in $) in Korea (Republic) in 2006 to that in 2007?
Provide a succinct answer. 1.34. What is the ratio of the Expenses (in $) in Luxembourg in 2006 to that in 2007?
Offer a very short reply. 0.97. What is the ratio of the Expenses (in $) in United States in 2006 to that in 2007?
Your answer should be very brief. 0.91. What is the ratio of the Expenses (in $) in Jordan in 2006 to that in 2008?
Keep it short and to the point. 2.12. What is the ratio of the Expenses (in $) in Korea (Republic) in 2006 to that in 2008?
Ensure brevity in your answer.  1.14. What is the ratio of the Expenses (in $) in Luxembourg in 2006 to that in 2008?
Provide a succinct answer. 0.92. What is the ratio of the Expenses (in $) in United States in 2006 to that in 2008?
Keep it short and to the point. 0.69. What is the ratio of the Expenses (in $) of Jordan in 2006 to that in 2009?
Provide a succinct answer. 6.99. What is the ratio of the Expenses (in $) of Korea (Republic) in 2006 to that in 2009?
Your answer should be compact. 0.93. What is the ratio of the Expenses (in $) in Luxembourg in 2006 to that in 2009?
Your answer should be very brief. 0.85. What is the ratio of the Expenses (in $) in United States in 2006 to that in 2009?
Provide a succinct answer. 0.57. What is the ratio of the Expenses (in $) of Jordan in 2006 to that in 2010?
Provide a short and direct response. 5.61. What is the ratio of the Expenses (in $) of Korea (Republic) in 2006 to that in 2010?
Provide a succinct answer. 1.08. What is the ratio of the Expenses (in $) of Luxembourg in 2006 to that in 2010?
Your response must be concise. 0.78. What is the ratio of the Expenses (in $) of United States in 2006 to that in 2010?
Offer a very short reply. 0.69. What is the ratio of the Expenses (in $) of Jordan in 2006 to that in 2011?
Give a very brief answer. 6.25. What is the ratio of the Expenses (in $) of Korea (Republic) in 2006 to that in 2011?
Provide a succinct answer. 1.01. What is the ratio of the Expenses (in $) in Luxembourg in 2006 to that in 2011?
Keep it short and to the point. 0.69. What is the ratio of the Expenses (in $) in United States in 2006 to that in 2011?
Your answer should be very brief. 0.7. What is the ratio of the Expenses (in $) in Jordan in 2007 to that in 2008?
Your answer should be compact. 5.63. What is the ratio of the Expenses (in $) in Korea (Republic) in 2007 to that in 2008?
Offer a very short reply. 0.85. What is the ratio of the Expenses (in $) in Luxembourg in 2007 to that in 2008?
Offer a very short reply. 0.95. What is the ratio of the Expenses (in $) of United States in 2007 to that in 2008?
Your answer should be very brief. 0.75. What is the ratio of the Expenses (in $) of Jordan in 2007 to that in 2009?
Your answer should be very brief. 18.54. What is the ratio of the Expenses (in $) in Korea (Republic) in 2007 to that in 2009?
Your response must be concise. 0.69. What is the ratio of the Expenses (in $) of Luxembourg in 2007 to that in 2009?
Your answer should be compact. 0.88. What is the ratio of the Expenses (in $) in United States in 2007 to that in 2009?
Offer a very short reply. 0.62. What is the ratio of the Expenses (in $) in Jordan in 2007 to that in 2010?
Make the answer very short. 14.88. What is the ratio of the Expenses (in $) of Korea (Republic) in 2007 to that in 2010?
Your answer should be very brief. 0.8. What is the ratio of the Expenses (in $) in Luxembourg in 2007 to that in 2010?
Make the answer very short. 0.8. What is the ratio of the Expenses (in $) in United States in 2007 to that in 2010?
Offer a very short reply. 0.75. What is the ratio of the Expenses (in $) in Jordan in 2007 to that in 2011?
Give a very brief answer. 16.59. What is the ratio of the Expenses (in $) of Korea (Republic) in 2007 to that in 2011?
Keep it short and to the point. 0.75. What is the ratio of the Expenses (in $) of Luxembourg in 2007 to that in 2011?
Provide a short and direct response. 0.71. What is the ratio of the Expenses (in $) of United States in 2007 to that in 2011?
Your answer should be very brief. 0.76. What is the ratio of the Expenses (in $) of Jordan in 2008 to that in 2009?
Offer a terse response. 3.29. What is the ratio of the Expenses (in $) in Korea (Republic) in 2008 to that in 2009?
Make the answer very short. 0.81. What is the ratio of the Expenses (in $) in Luxembourg in 2008 to that in 2009?
Ensure brevity in your answer.  0.93. What is the ratio of the Expenses (in $) in United States in 2008 to that in 2009?
Give a very brief answer. 0.83. What is the ratio of the Expenses (in $) in Jordan in 2008 to that in 2010?
Make the answer very short. 2.64. What is the ratio of the Expenses (in $) in Korea (Republic) in 2008 to that in 2010?
Make the answer very short. 0.94. What is the ratio of the Expenses (in $) in Luxembourg in 2008 to that in 2010?
Offer a terse response. 0.84. What is the ratio of the Expenses (in $) of Jordan in 2008 to that in 2011?
Provide a succinct answer. 2.95. What is the ratio of the Expenses (in $) in Korea (Republic) in 2008 to that in 2011?
Make the answer very short. 0.88. What is the ratio of the Expenses (in $) of Luxembourg in 2008 to that in 2011?
Provide a succinct answer. 0.75. What is the ratio of the Expenses (in $) in United States in 2008 to that in 2011?
Your response must be concise. 1.02. What is the ratio of the Expenses (in $) of Jordan in 2009 to that in 2010?
Your answer should be very brief. 0.8. What is the ratio of the Expenses (in $) in Korea (Republic) in 2009 to that in 2010?
Make the answer very short. 1.16. What is the ratio of the Expenses (in $) of Luxembourg in 2009 to that in 2010?
Offer a very short reply. 0.91. What is the ratio of the Expenses (in $) of United States in 2009 to that in 2010?
Your answer should be very brief. 1.21. What is the ratio of the Expenses (in $) in Jordan in 2009 to that in 2011?
Give a very brief answer. 0.9. What is the ratio of the Expenses (in $) of Korea (Republic) in 2009 to that in 2011?
Offer a very short reply. 1.09. What is the ratio of the Expenses (in $) in Luxembourg in 2009 to that in 2011?
Your response must be concise. 0.81. What is the ratio of the Expenses (in $) in United States in 2009 to that in 2011?
Offer a very short reply. 1.23. What is the ratio of the Expenses (in $) in Jordan in 2010 to that in 2011?
Your answer should be compact. 1.12. What is the ratio of the Expenses (in $) of Korea (Republic) in 2010 to that in 2011?
Offer a very short reply. 0.94. What is the ratio of the Expenses (in $) in Luxembourg in 2010 to that in 2011?
Offer a very short reply. 0.89. What is the ratio of the Expenses (in $) of United States in 2010 to that in 2011?
Offer a very short reply. 1.02. What is the difference between the highest and the second highest Expenses (in $) of Jordan?
Provide a succinct answer. 8.96e+08. What is the difference between the highest and the second highest Expenses (in $) in Korea (Republic)?
Provide a succinct answer. 2.81e+12. What is the difference between the highest and the second highest Expenses (in $) of Luxembourg?
Offer a very short reply. 1.10e+08. What is the difference between the highest and the second highest Expenses (in $) in United States?
Your answer should be very brief. 6.33e+1. What is the difference between the highest and the lowest Expenses (in $) of Jordan?
Your answer should be very brief. 1.36e+09. What is the difference between the highest and the lowest Expenses (in $) in Korea (Republic)?
Give a very brief answer. 1.22e+13. What is the difference between the highest and the lowest Expenses (in $) in Luxembourg?
Provide a succinct answer. 5.87e+08. What is the difference between the highest and the lowest Expenses (in $) of United States?
Provide a succinct answer. 1.81e+11. 